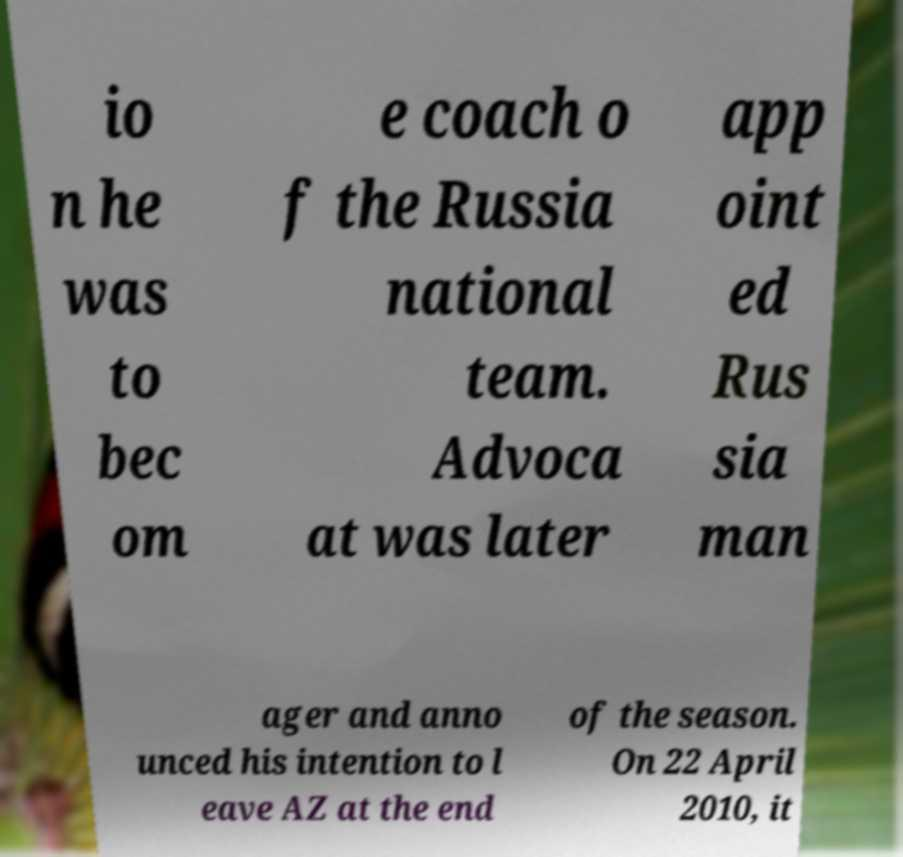What messages or text are displayed in this image? I need them in a readable, typed format. io n he was to bec om e coach o f the Russia national team. Advoca at was later app oint ed Rus sia man ager and anno unced his intention to l eave AZ at the end of the season. On 22 April 2010, it 